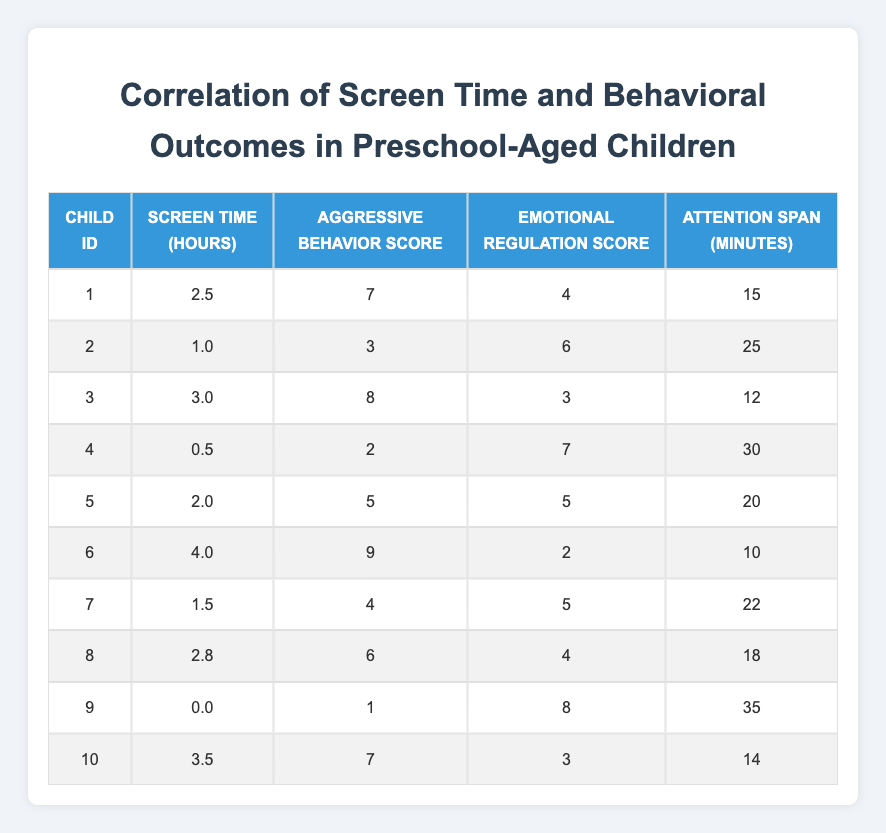What is the screen time for Child ID 4? By looking at the table, I can find the row corresponding to Child ID 4, which shows that Screen Time (Hours) is 0.5 for this child.
Answer: 0.5 What is the aggressive behavior score for the child with the highest screen time? Scanning the table, Child ID 6 has the highest Screen Time (4.0 hours). The corresponding Aggressive Behavior Score for this child is 9.
Answer: 9 What is the average emotional regulation score for all children? To find the average emotional regulation score, I sum the scores for all children (4 + 6 + 3 + 7 + 5 + 2 + 5 + 4 + 8 + 3 = 43) and then divide by the number of children (10). So, the average is 43 / 10 = 4.3.
Answer: 4.3 Is there a child with a screen time of 0 hours? In the table, I check each entry for any child with Screen Time (Hours) equal to 0. I find that Child ID 9 has a screen time of 0.0 hours. Therefore, the answer is yes.
Answer: Yes Which child has the longest attention span, and what is that duration? Looking through the Attention Span (Minutes) column, I identify that Child ID 9 has the longest attention span of 35 minutes.
Answer: 35 What is the difference in aggressive behavior scores between the child with the highest score and the child with the lowest score? Child ID 6 has the highest Aggressive Behavior Score of 9, while Child ID 9 has the lowest score of 1. The difference is calculated as 9 - 1 = 8.
Answer: 8 What is the median screen time of all the children? To find the median, I first order the screen times: 0.0, 0.5, 1.0, 1.5, 2.0, 2.5, 2.8, 3.0, 3.5, 4.0. Since there are 10 data points, the median is the average of the 5th (2.0) and 6th (2.5) values. So, (2.0 + 2.5) / 2 = 2.25.
Answer: 2.25 Are there more children with screen time below 2 hours than above 2 hours? I count the children below 2 hours: Child IDs 4 (0.5), 2 (1.0), 7 (1.5), and 9 (0.0), which totals 4. For above 2 hours, Child IDs 1 (2.5), 3 (3.0), 6 (4.0), 5 (2.0), 8 (2.8), and 10 (3.5) total 6. Thus, there are more children above 2 hours.
Answer: No What is the average attention span for children with aggressive behavior scores above 5? I filter for children with scores above 5: Child IDs 3 (12), 6 (10), 1 (15), 10 (14), and 5 (20) which results in the average (12 + 10 + 15 + 14 + 20)/5 = 14.2.
Answer: 14.2 